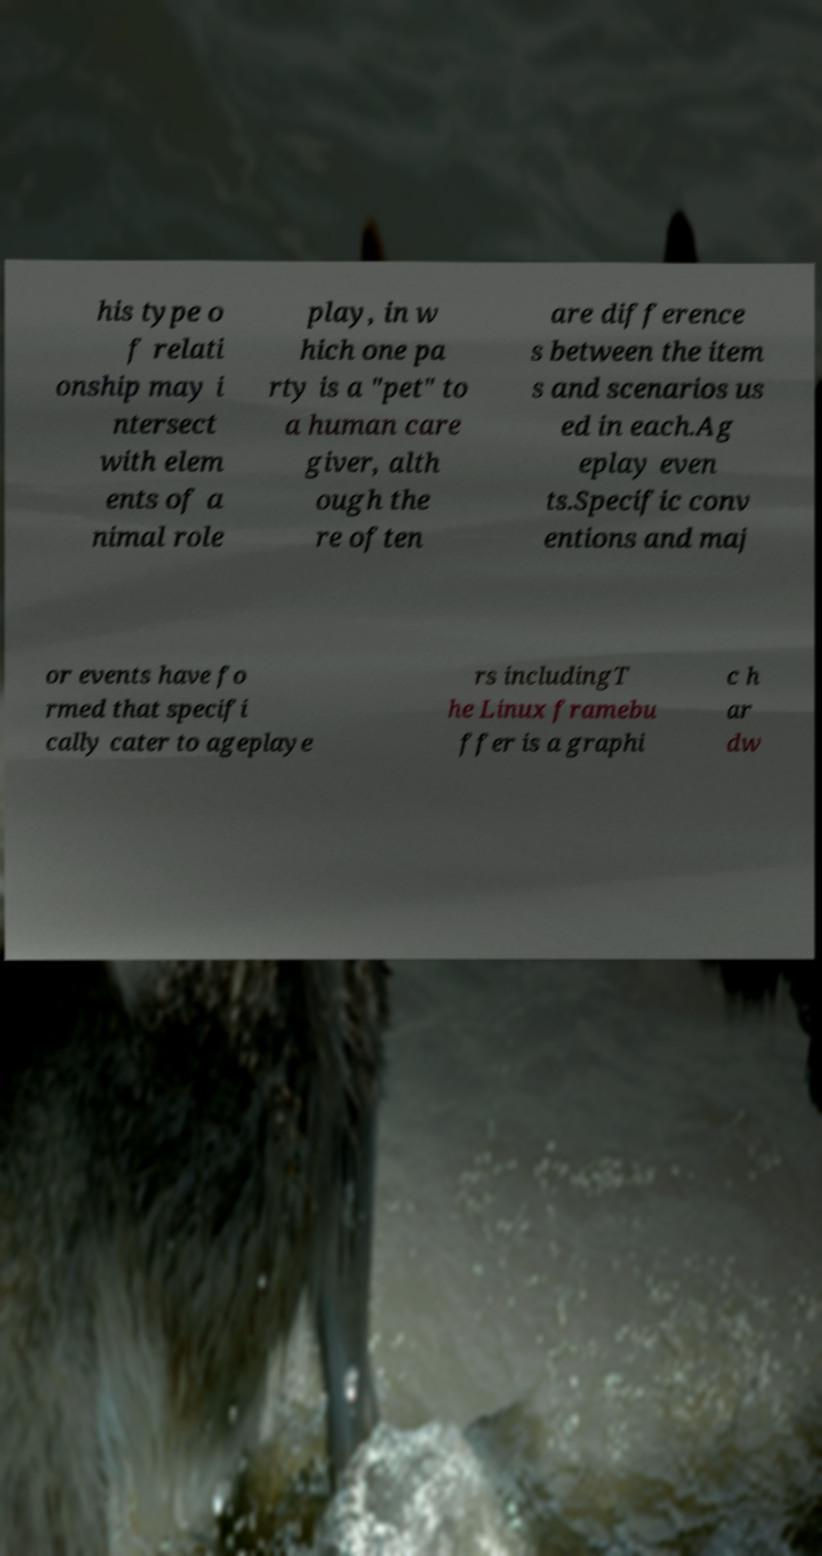Can you accurately transcribe the text from the provided image for me? his type o f relati onship may i ntersect with elem ents of a nimal role play, in w hich one pa rty is a "pet" to a human care giver, alth ough the re often are difference s between the item s and scenarios us ed in each.Ag eplay even ts.Specific conv entions and maj or events have fo rmed that specifi cally cater to ageplaye rs includingT he Linux framebu ffer is a graphi c h ar dw 